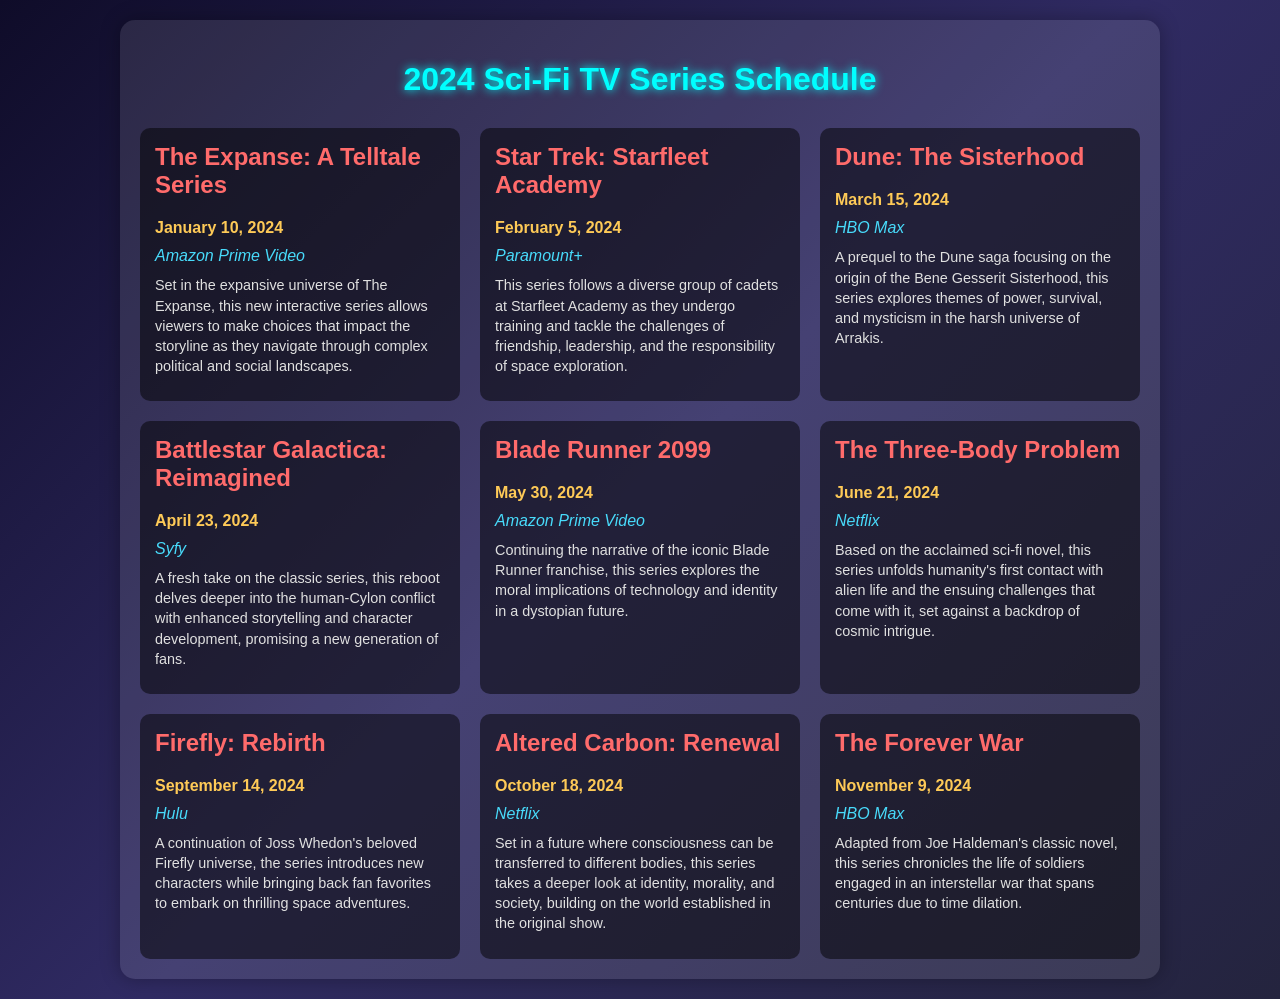What is the premiere date of The Expanse: A Telltale Series? The premiere date for The Expanse: A Telltale Series is explicitly provided in the document.
Answer: January 10, 2024 Which network will air Star Trek: Starfleet Academy? The document lists the network that will air Star Trek: Starfleet Academy among other shows in the schedule.
Answer: Paramount+ What is the main theme of Dune: The Sisterhood? The description of Dune: The Sisterhood highlights its focus on themes of power, survival, and mysticism.
Answer: Power, survival, and mysticism When will Battlestar Galactica: Reimagined be released? The scheduled release date for Battlestar Galactica: Reimagined is found directly in the document.
Answer: April 23, 2024 How many sci-fi series are premiering in May 2024? The schedule lists two series set for premiere in May, which needs to be counted from the list.
Answer: 1 Who is the creator of Firefly: Rebirth? The description states that Firefly: Rebirth is a continuation of Joss Whedon's beloved Firefly universe.
Answer: Joss Whedon What type of series is Blade Runner 2099 described as? The document characterizes Blade Runner 2099 in terms of its exploration of technology and identity in a dystopian future.
Answer: Dystopian Which series is based on a classic novel by Joe Haldeman? The Forever War is specifically mentioned in the document as being adapted from Joe Haldeman's classic novel.
Answer: The Forever War 